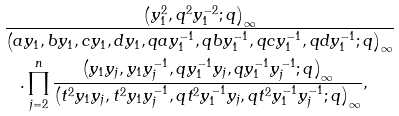<formula> <loc_0><loc_0><loc_500><loc_500>& \frac { \left ( y _ { 1 } ^ { 2 } , q ^ { 2 } y _ { 1 } ^ { - 2 } ; q \right ) _ { \infty } } { \left ( a y _ { 1 } , b y _ { 1 } , c y _ { 1 } , d y _ { 1 } , q a y _ { 1 } ^ { - 1 } , q b y _ { 1 } ^ { - 1 } , q c y _ { 1 } ^ { - 1 } , q d y _ { 1 } ^ { - 1 } ; q \right ) _ { \infty } } \\ & \quad . \prod _ { j = 2 } ^ { n } \frac { \left ( y _ { 1 } y _ { j } , y _ { 1 } y _ { j } ^ { - 1 } , q y _ { 1 } ^ { - 1 } y _ { j } , q y _ { 1 } ^ { - 1 } y _ { j } ^ { - 1 } ; q \right ) _ { \infty } } { \left ( t ^ { 2 } y _ { 1 } y _ { j } , t ^ { 2 } y _ { 1 } y _ { j } ^ { - 1 } , q t ^ { 2 } y _ { 1 } ^ { - 1 } y _ { j } , q t ^ { 2 } y _ { 1 } ^ { - 1 } y _ { j } ^ { - 1 } ; q \right ) _ { \infty } } ,</formula> 